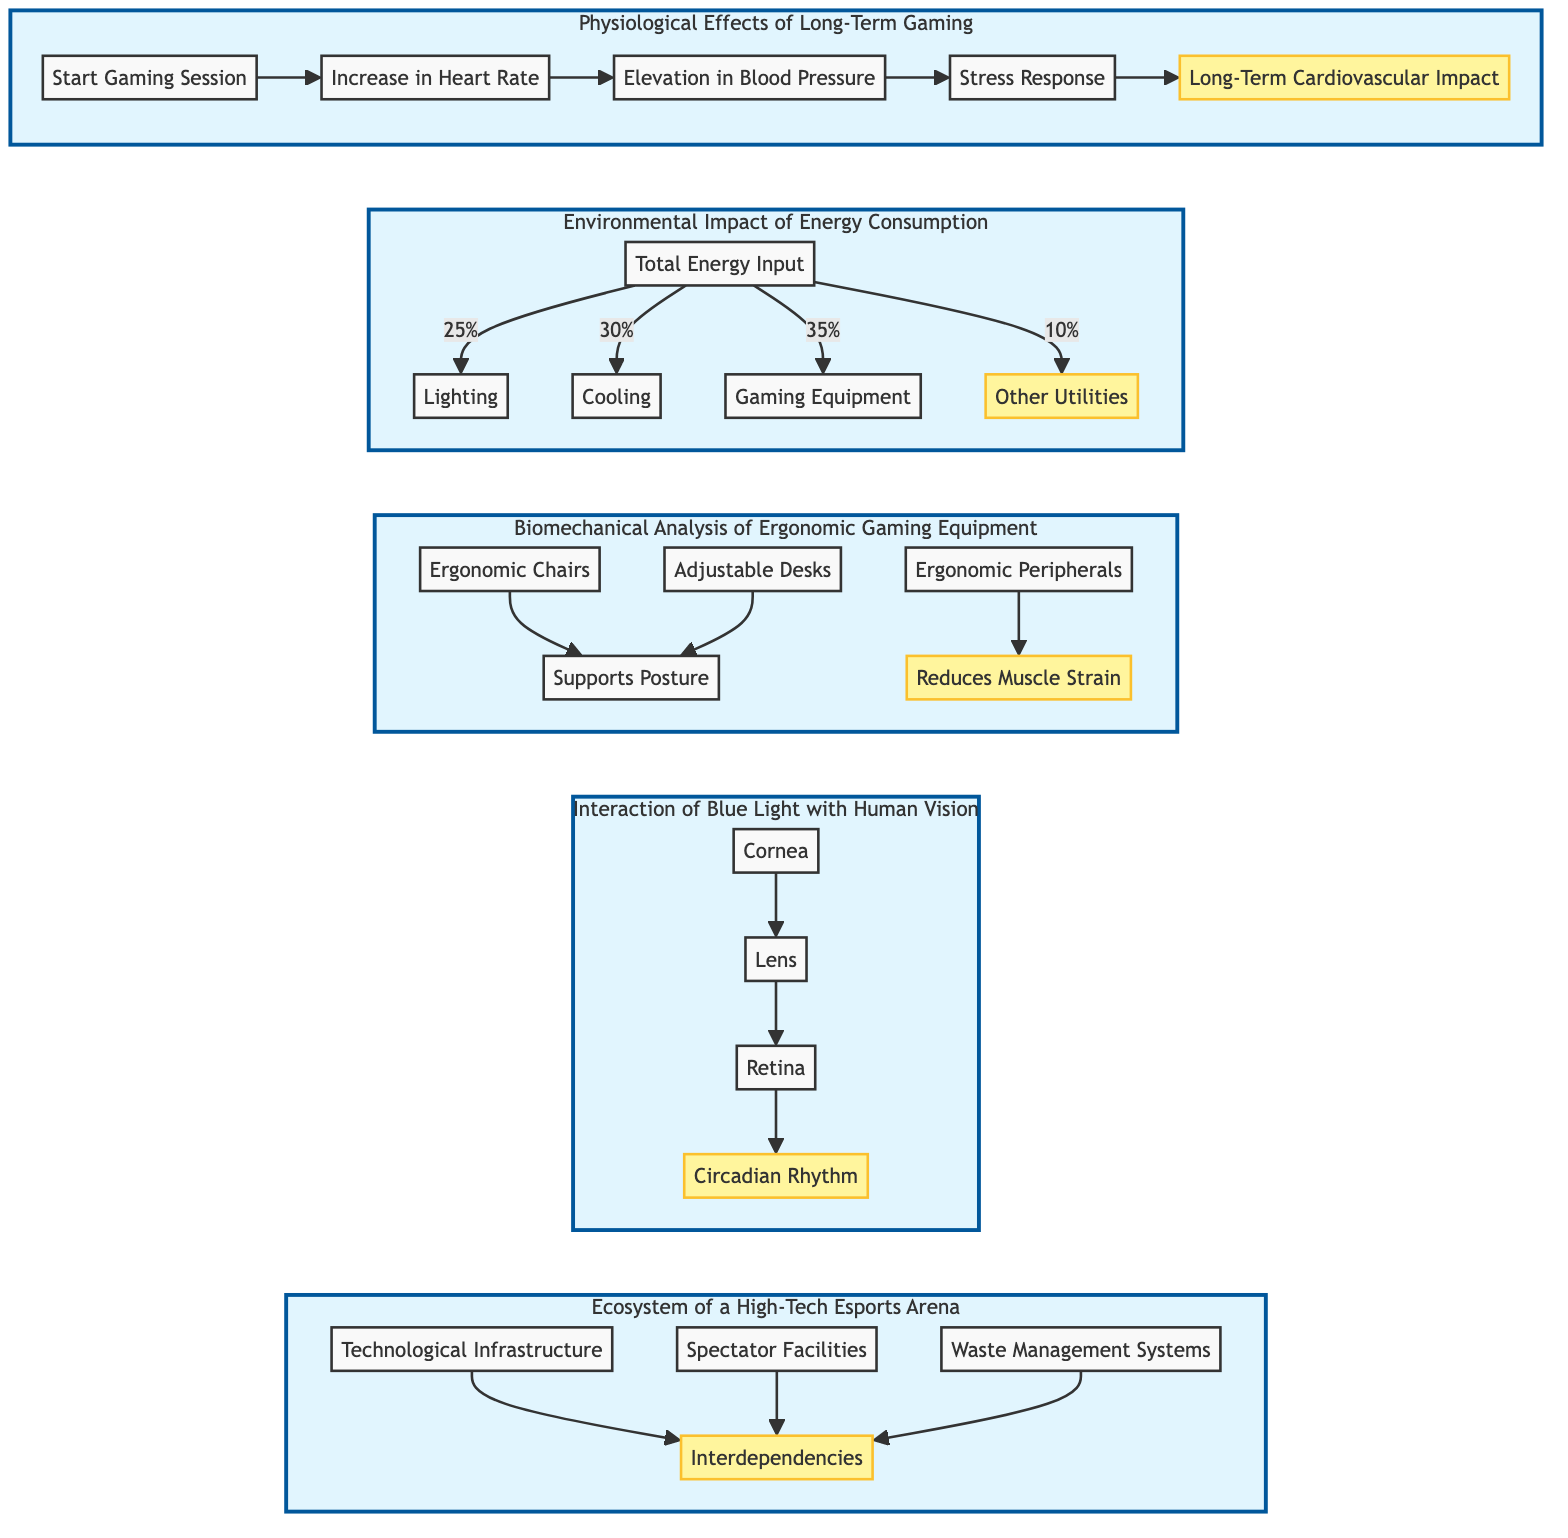What node immediately follows "Start Gaming Session"? The diagram shows a flow from the node "Start Gaming Session" to the next node labeled "Increase in Heart Rate."
Answer: Increase in Heart Rate What percentage of energy input is allocated to gaming equipment? The Sankey diagram indicates that 35% of the total energy input is allocated to gaming equipment, clearly represented in the section corresponding to Energy Consumption.
Answer: 35% How many sections are there in the biomechanical analysis of ergonomic gaming equipment? The diagram illustrates three distinct nodes that focus on ergonomic chairs, adjustable desks, and ergonomic peripherals, which indicates that there are three sections in this part of the schematic.
Answer: 3 What is the final effect of blue light on human physiology according to this diagram? The flow of the diagram indicates that the effect of blue light ultimately impacts the "Circadian Rhythm" following the passage through the cornea, lens, and retina, connecting the series of nodes.
Answer: Circadian Rhythm How do ergonomic peripherals impact muscle strain? The diagram maps the relationship from "Ergonomic Peripherals" to the node "Reduces Muscle Strain," showing that ergonomic peripherals specifically contribute to this reduction in strain based on their functionality.
Answer: Reduces Muscle Strain What interdependencies are illustrated in the esports arena? The systems diagram represents interdependencies between technological infrastructure, spectator facilities, and waste management systems, indicating a complex relationship in managing the esports arena ecosystem.
Answer: Interdependencies Which aspect is highlighted in the physiological effects of long-term gaming? In the physiological effects subgraph, the last node "Long-Term Cardiovascular Impact" is highlighted, signifying it as an important outcome of the gaming flow.
Answer: Long-Term Cardiovascular Impact What is the energy consumption percentage for cooling? The diagram clearly indicates that 30% of the total energy input is directed to cooling, as represented in the Energy Consumption section.
Answer: 30% 